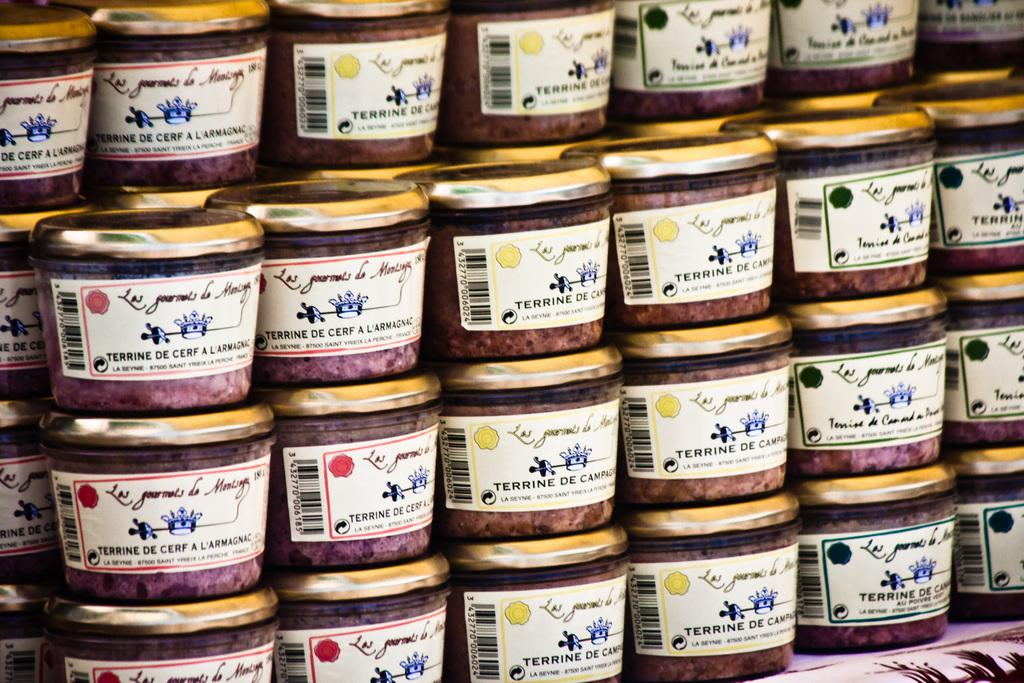<image>
Relay a brief, clear account of the picture shown. several containers of Terrine De Cerf a L'armagnac on display 